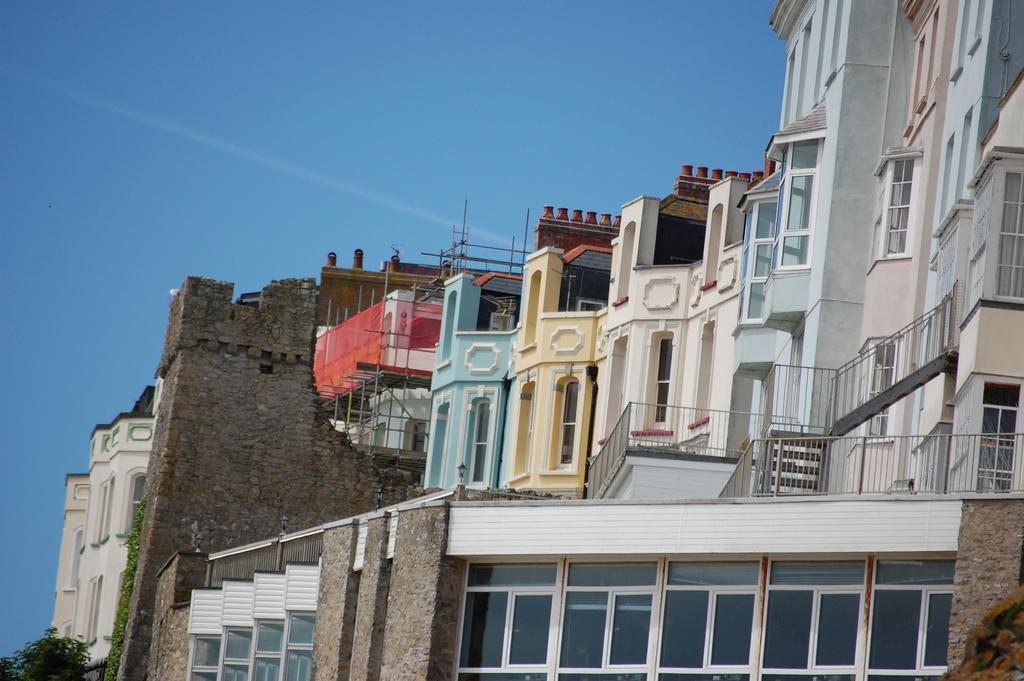Could you give a brief overview of what you see in this image? In the picture I can see buildings, fence, a tree and some other objects. In the background I can see the sky. 